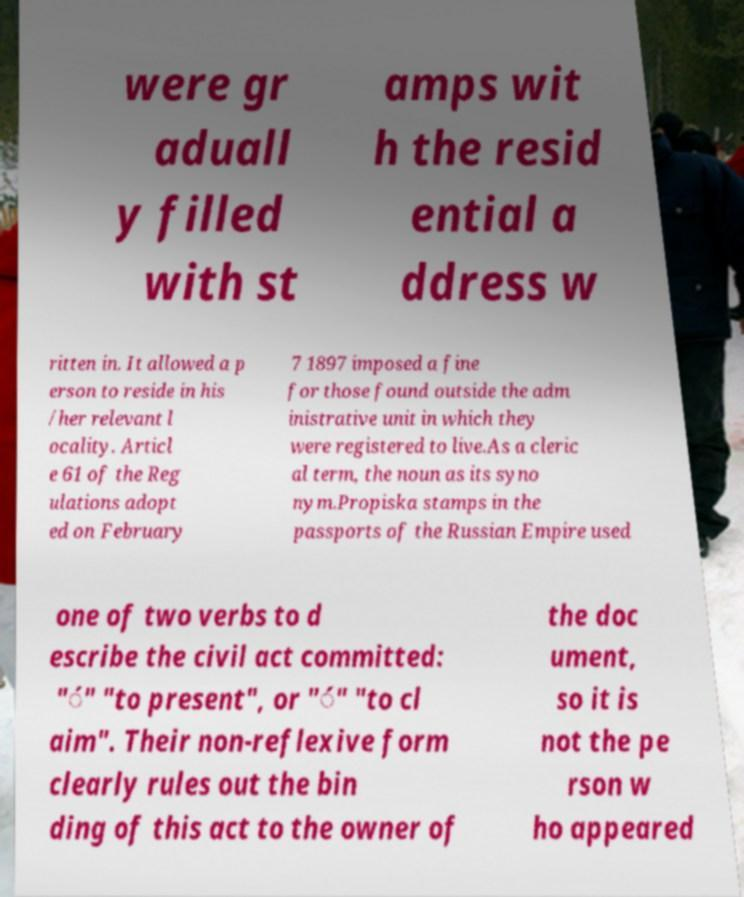Please identify and transcribe the text found in this image. were gr aduall y filled with st amps wit h the resid ential a ddress w ritten in. It allowed a p erson to reside in his /her relevant l ocality. Articl e 61 of the Reg ulations adopt ed on February 7 1897 imposed a fine for those found outside the adm inistrative unit in which they were registered to live.As a cleric al term, the noun as its syno nym.Propiska stamps in the passports of the Russian Empire used one of two verbs to d escribe the civil act committed: "́" "to present", or "́" "to cl aim". Their non-reflexive form clearly rules out the bin ding of this act to the owner of the doc ument, so it is not the pe rson w ho appeared 